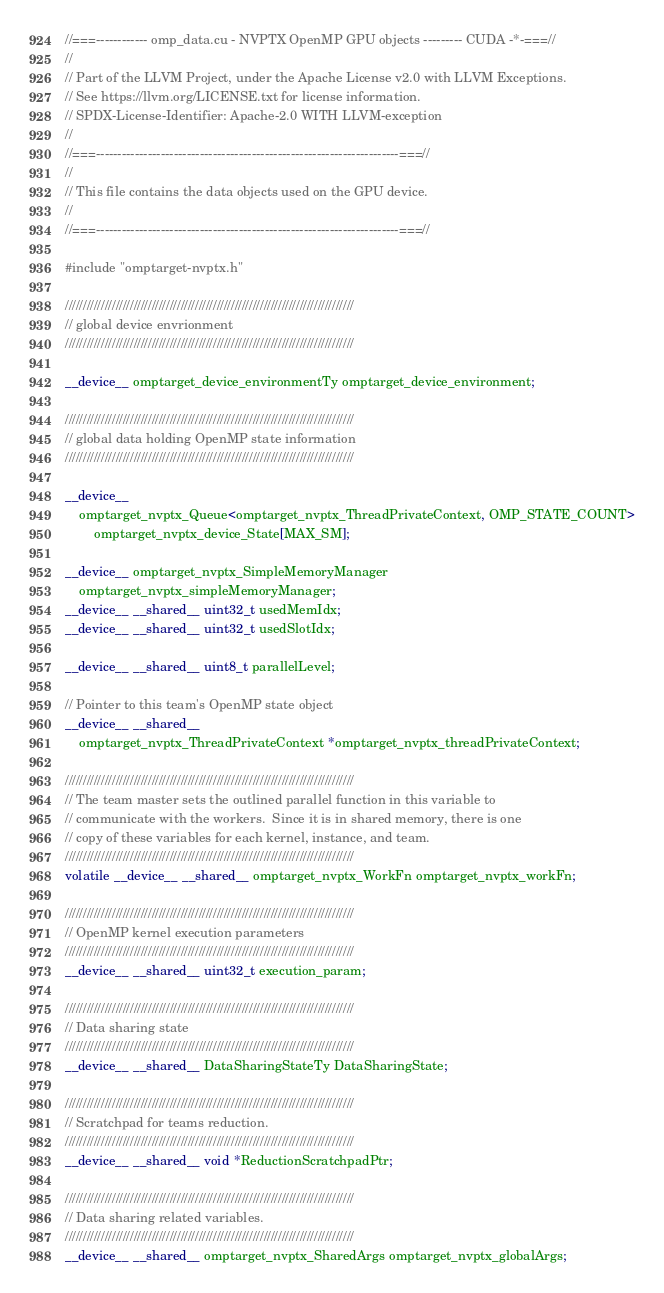Convert code to text. <code><loc_0><loc_0><loc_500><loc_500><_Cuda_>//===------------ omp_data.cu - NVPTX OpenMP GPU objects --------- CUDA -*-===//
//
// Part of the LLVM Project, under the Apache License v2.0 with LLVM Exceptions.
// See https://llvm.org/LICENSE.txt for license information.
// SPDX-License-Identifier: Apache-2.0 WITH LLVM-exception
//
//===----------------------------------------------------------------------===//
//
// This file contains the data objects used on the GPU device.
//
//===----------------------------------------------------------------------===//

#include "omptarget-nvptx.h"

////////////////////////////////////////////////////////////////////////////////
// global device envrionment
////////////////////////////////////////////////////////////////////////////////

__device__ omptarget_device_environmentTy omptarget_device_environment;

////////////////////////////////////////////////////////////////////////////////
// global data holding OpenMP state information
////////////////////////////////////////////////////////////////////////////////

__device__
    omptarget_nvptx_Queue<omptarget_nvptx_ThreadPrivateContext, OMP_STATE_COUNT>
        omptarget_nvptx_device_State[MAX_SM];

__device__ omptarget_nvptx_SimpleMemoryManager
    omptarget_nvptx_simpleMemoryManager;
__device__ __shared__ uint32_t usedMemIdx;
__device__ __shared__ uint32_t usedSlotIdx;

__device__ __shared__ uint8_t parallelLevel;

// Pointer to this team's OpenMP state object
__device__ __shared__
    omptarget_nvptx_ThreadPrivateContext *omptarget_nvptx_threadPrivateContext;

////////////////////////////////////////////////////////////////////////////////
// The team master sets the outlined parallel function in this variable to
// communicate with the workers.  Since it is in shared memory, there is one
// copy of these variables for each kernel, instance, and team.
////////////////////////////////////////////////////////////////////////////////
volatile __device__ __shared__ omptarget_nvptx_WorkFn omptarget_nvptx_workFn;

////////////////////////////////////////////////////////////////////////////////
// OpenMP kernel execution parameters
////////////////////////////////////////////////////////////////////////////////
__device__ __shared__ uint32_t execution_param;

////////////////////////////////////////////////////////////////////////////////
// Data sharing state
////////////////////////////////////////////////////////////////////////////////
__device__ __shared__ DataSharingStateTy DataSharingState;

////////////////////////////////////////////////////////////////////////////////
// Scratchpad for teams reduction.
////////////////////////////////////////////////////////////////////////////////
__device__ __shared__ void *ReductionScratchpadPtr;

////////////////////////////////////////////////////////////////////////////////
// Data sharing related variables.
////////////////////////////////////////////////////////////////////////////////
__device__ __shared__ omptarget_nvptx_SharedArgs omptarget_nvptx_globalArgs;
</code> 